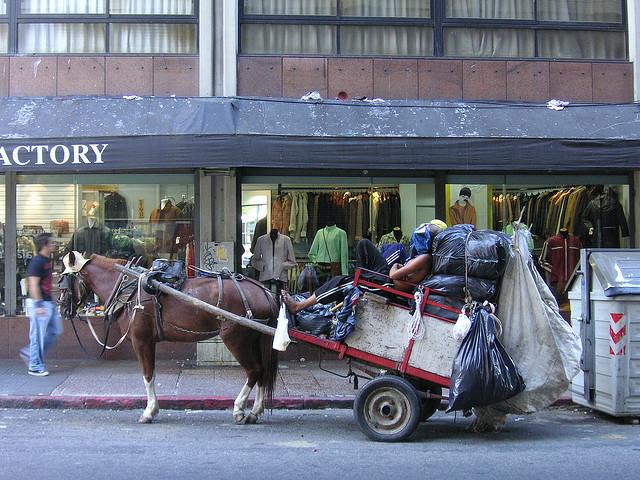What is the horse pulling?
Be succinct. Cart. How many wheels are on the cart?
Be succinct. 2. What color is the horse?
Quick response, please. Brown. Where was this photo taken?
Concise answer only. Street. Is that a factory?
Short answer required. Yes. 